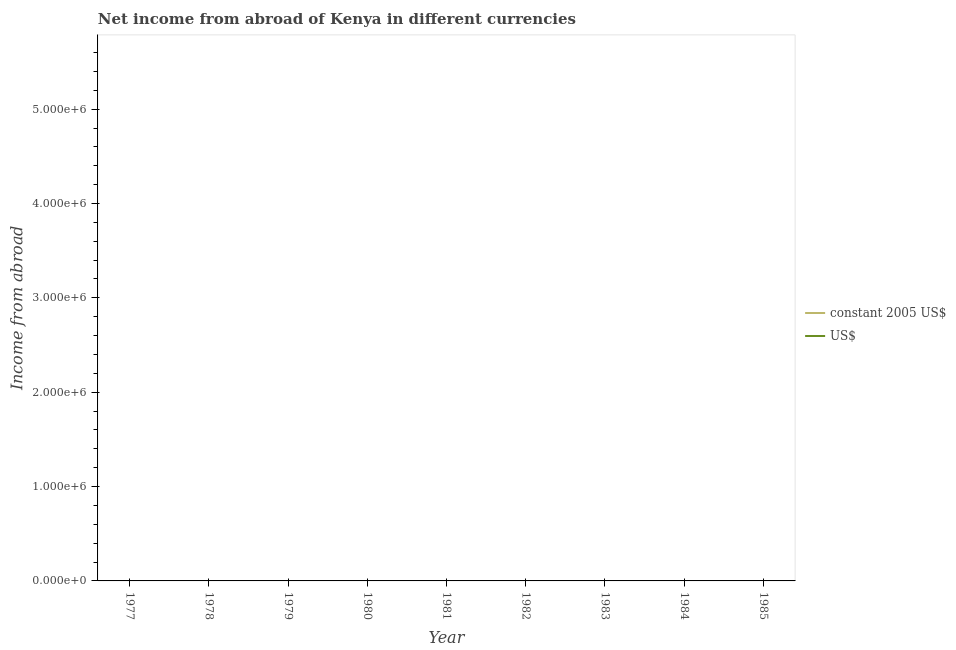How many different coloured lines are there?
Offer a terse response. 0. Does the line corresponding to income from abroad in constant 2005 us$ intersect with the line corresponding to income from abroad in us$?
Your answer should be compact. No. What is the income from abroad in us$ in 1985?
Your response must be concise. 0. What is the average income from abroad in constant 2005 us$ per year?
Provide a short and direct response. 0. In how many years, is the income from abroad in us$ greater than the average income from abroad in us$ taken over all years?
Your response must be concise. 0. Is the income from abroad in constant 2005 us$ strictly greater than the income from abroad in us$ over the years?
Your answer should be very brief. No. Is the income from abroad in us$ strictly less than the income from abroad in constant 2005 us$ over the years?
Offer a very short reply. No. How many lines are there?
Provide a short and direct response. 0. Are the values on the major ticks of Y-axis written in scientific E-notation?
Your answer should be compact. Yes. Where does the legend appear in the graph?
Your response must be concise. Center right. How many legend labels are there?
Keep it short and to the point. 2. What is the title of the graph?
Your answer should be compact. Net income from abroad of Kenya in different currencies. What is the label or title of the Y-axis?
Give a very brief answer. Income from abroad. What is the Income from abroad of US$ in 1978?
Give a very brief answer. 0. What is the Income from abroad of constant 2005 US$ in 1979?
Your response must be concise. 0. What is the Income from abroad in constant 2005 US$ in 1980?
Provide a succinct answer. 0. What is the Income from abroad of US$ in 1980?
Provide a short and direct response. 0. What is the Income from abroad of constant 2005 US$ in 1981?
Provide a succinct answer. 0. What is the Income from abroad in US$ in 1981?
Provide a succinct answer. 0. What is the Income from abroad in US$ in 1983?
Your answer should be very brief. 0. What is the Income from abroad in constant 2005 US$ in 1984?
Your response must be concise. 0. What is the Income from abroad of constant 2005 US$ in 1985?
Ensure brevity in your answer.  0. What is the Income from abroad of US$ in 1985?
Give a very brief answer. 0. What is the total Income from abroad of US$ in the graph?
Ensure brevity in your answer.  0. What is the average Income from abroad of constant 2005 US$ per year?
Ensure brevity in your answer.  0. What is the average Income from abroad in US$ per year?
Your response must be concise. 0. 